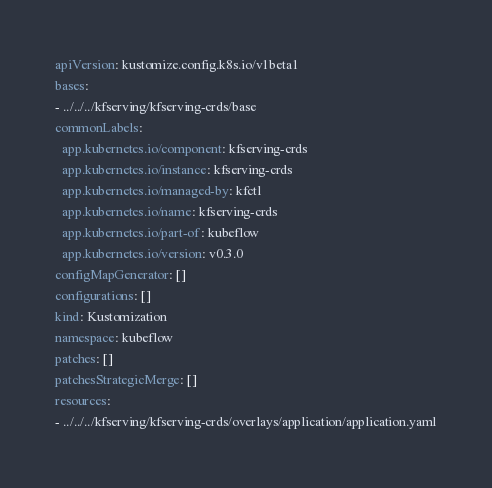<code> <loc_0><loc_0><loc_500><loc_500><_YAML_>apiVersion: kustomize.config.k8s.io/v1beta1
bases:
- ../../../kfserving/kfserving-crds/base
commonLabels:
  app.kubernetes.io/component: kfserving-crds
  app.kubernetes.io/instance: kfserving-crds
  app.kubernetes.io/managed-by: kfctl
  app.kubernetes.io/name: kfserving-crds
  app.kubernetes.io/part-of: kubeflow
  app.kubernetes.io/version: v0.3.0
configMapGenerator: []
configurations: []
kind: Kustomization
namespace: kubeflow
patches: []
patchesStrategicMerge: []
resources:
- ../../../kfserving/kfserving-crds/overlays/application/application.yaml
</code> 